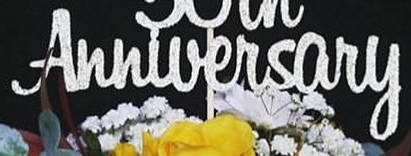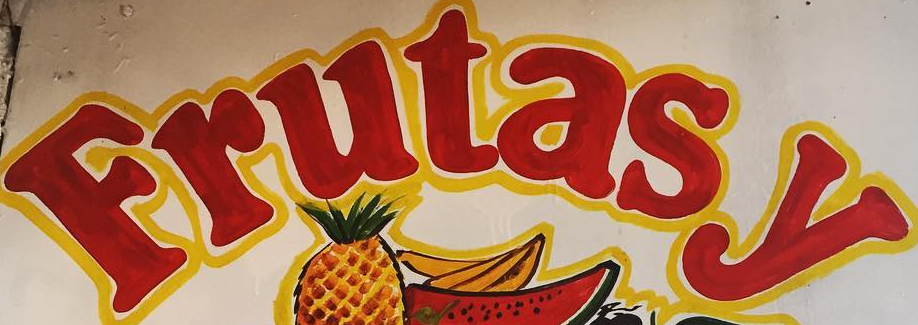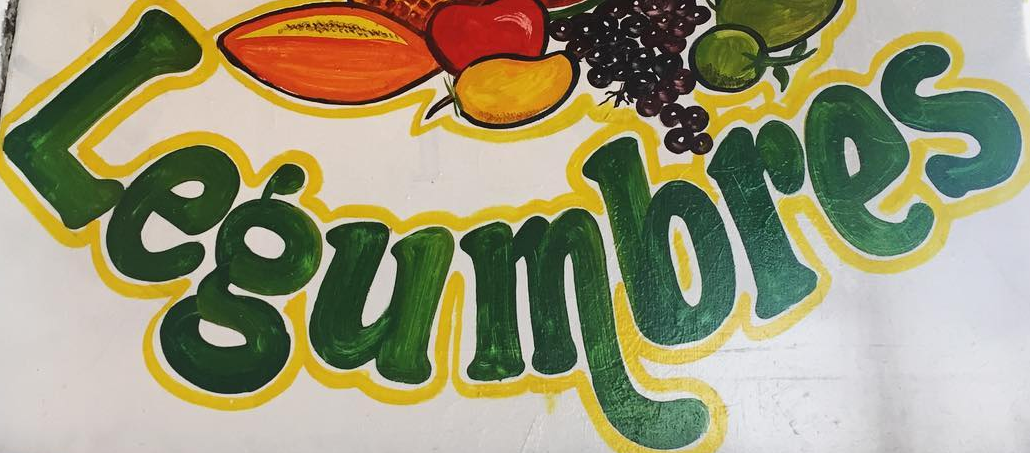Read the text from these images in sequence, separated by a semicolon. Anniversary; Frutasy; Legumbres 